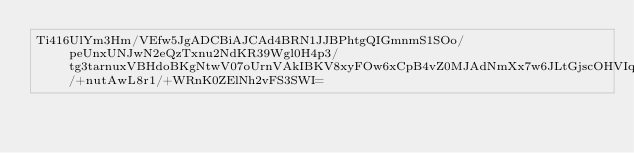<code> <loc_0><loc_0><loc_500><loc_500><_SML_>Ti416UlYm3Hm/VEfw5JgADCBiAJCAd4BRN1JJBPhtgQIGmnmS1SOo/peUnxUNJwN2eQzTxnu2NdKR39Wgl0H4p3/tg3tarnuxVBHdoBKgNtwV07oUrnVAkIBKV8xyFOw6xCpB4vZ0MJAdNmXx7w6JLtGjscOHVIq9cXITY8jmODxGUpR/+nutAwL8r1/+WRnK0ZElNh2vFS3SWI=</code> 